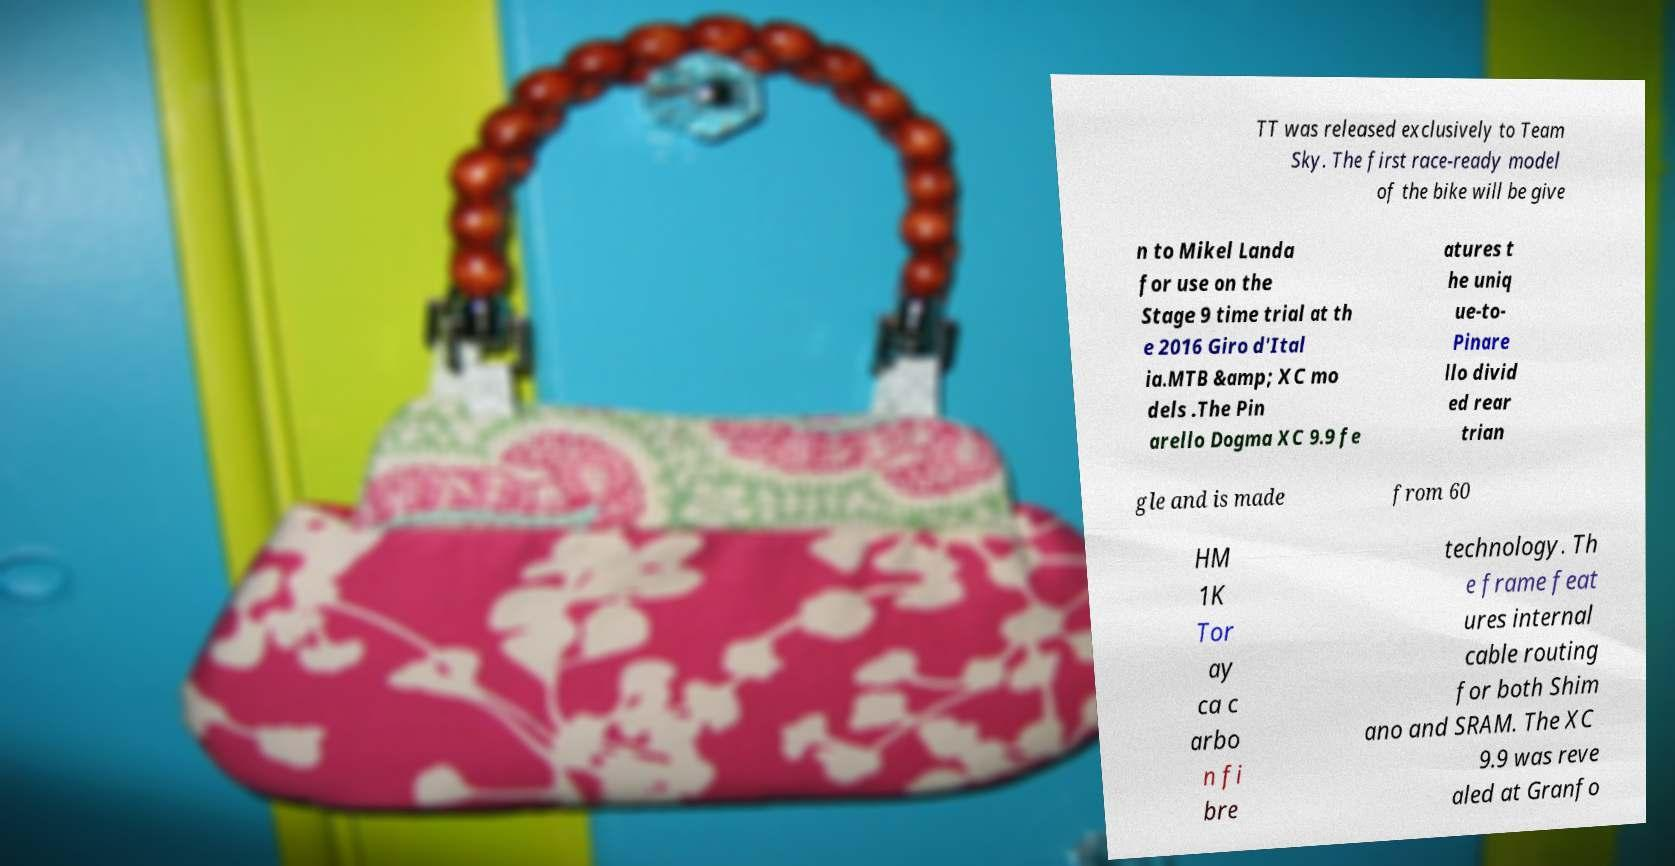Can you read and provide the text displayed in the image?This photo seems to have some interesting text. Can you extract and type it out for me? TT was released exclusively to Team Sky. The first race-ready model of the bike will be give n to Mikel Landa for use on the Stage 9 time trial at th e 2016 Giro d'Ital ia.MTB &amp; XC mo dels .The Pin arello Dogma XC 9.9 fe atures t he uniq ue-to- Pinare llo divid ed rear trian gle and is made from 60 HM 1K Tor ay ca c arbo n fi bre technology. Th e frame feat ures internal cable routing for both Shim ano and SRAM. The XC 9.9 was reve aled at Granfo 